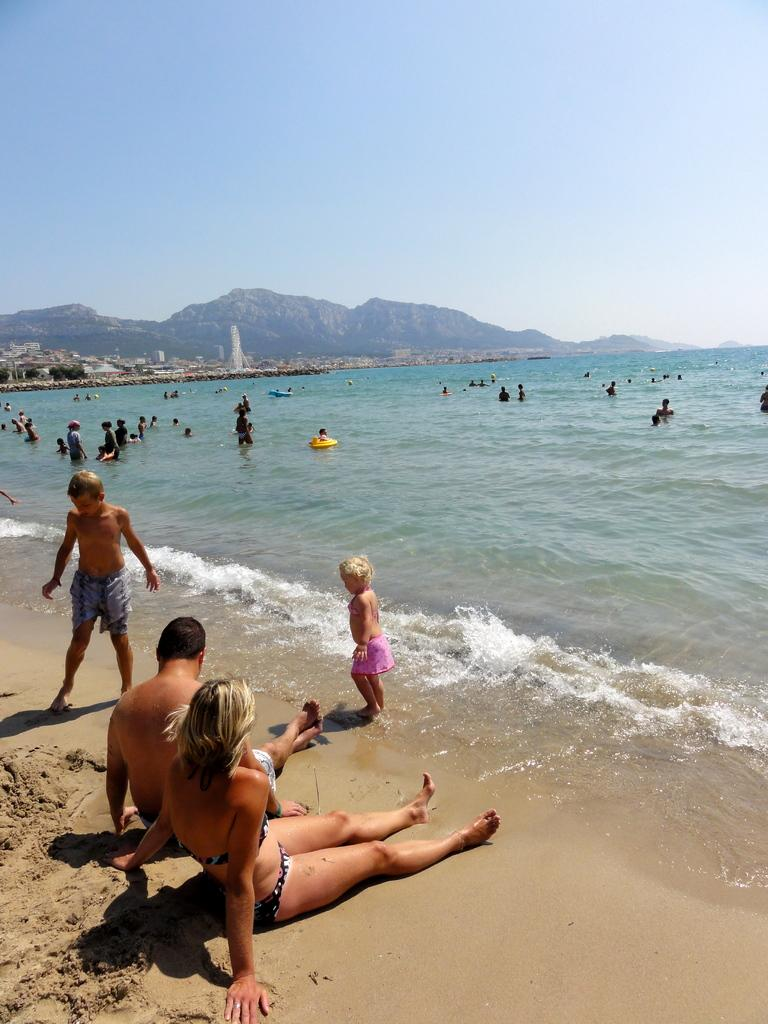How many people can be seen in the image? There are many people in the image. What natural setting is visible in the image? There is a sea shore in the image. What can be seen in the background of the image? There are hills visible in the background of the image. What is visible above the people and the sea shore? The sky is visible in the image. What type of scent can be detected in the image? There is no mention of a scent in the image, so it cannot be determined from the image. 